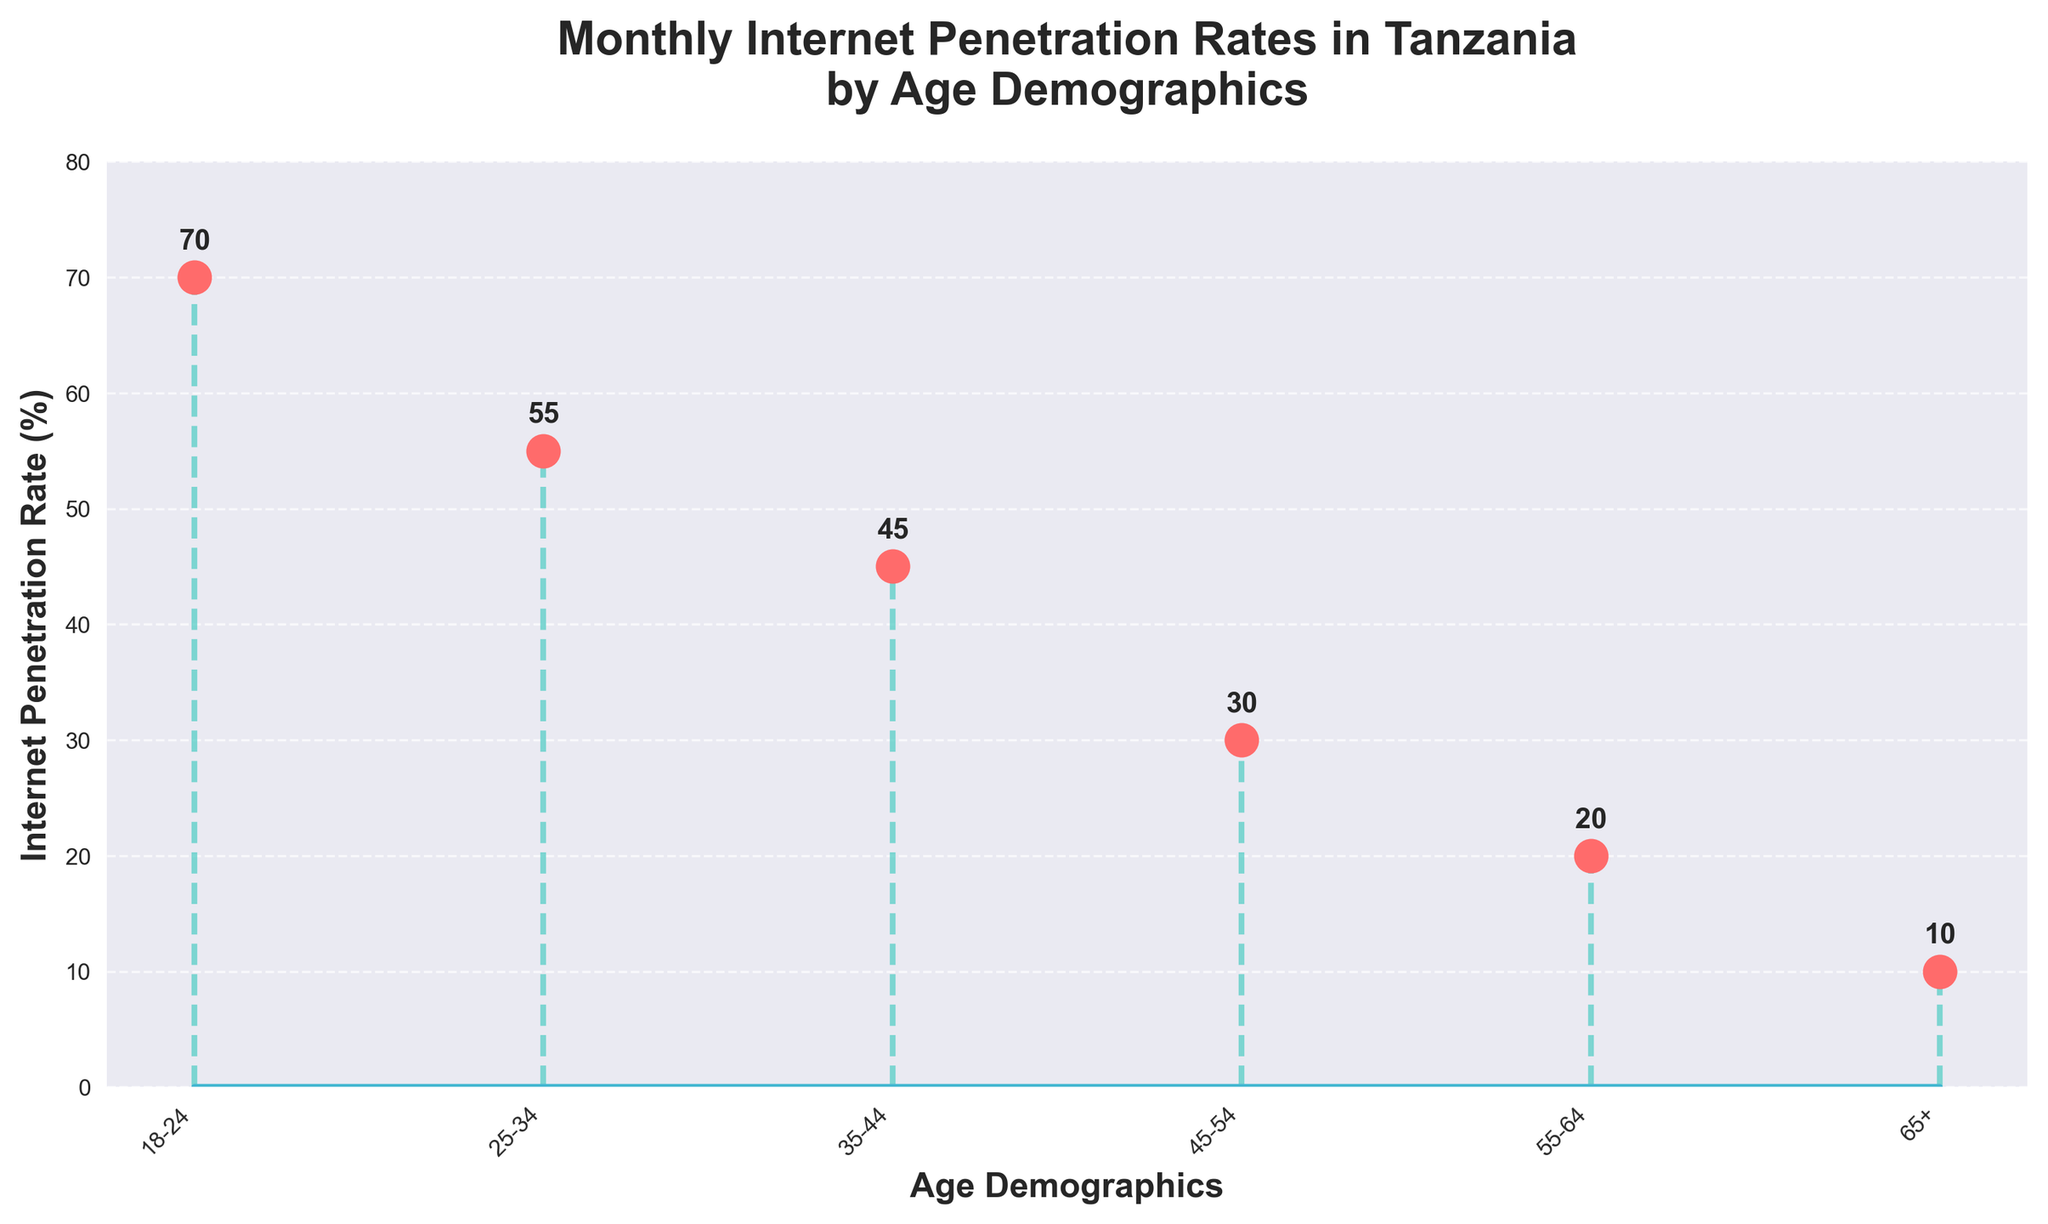What is the internet penetration rate for the 25-34 age demographic? Refer to the y-axis value aligned with the label "25-34" on the x-axis. This value is stated directly above the data point in the plot.
Answer: 55 What is the range of internet penetration rates in the plot? Identify the highest and lowest internet penetration rates from the y-axis values. The highest is 70 and the lowest is 10. Calculate the range as 70 - 10.
Answer: 60 Which age demographic has the lowest internet penetration rate? Find the demographic with the lowest y-axis value. The age demographic corresponding to this value is "65+".
Answer: 65+ How does the internet penetration rate for the 45-54 age group compare to the 18-24 age group? Compare the y-axis values for "45-54" and "18-24". The value for 45-54 is 30, and the value for 18-24 is 70.
Answer: 45-54 has less penetration What is the average internet penetration rate across all age demographics? Sum the internet penetration rates (70 + 55 + 45 + 30 + 20 + 10) and divide by the number of age demographics (6).
Answer: 38.33 By how much does the internet penetration rate decrease from the 18-24 age group to the 25-34 age group? Subtract the y-axis value for the 25-34 age group (55) from the y-axis value for the 18-24 age group (70).
Answer: 15 What is the internet penetration rate for the 55-64 age demographic? Refer to the y-axis value aligned with the label "55-64" on the x-axis. This value is stated directly above the data point in the plot.
Answer: 20 Which age demographic shows the largest drop in internet penetration rate compared to the previous group? Calculate the differences between consecutive age group y-values (70-55, 55-45, 45-30, 30-20, 20-10) and identify the largest drop (15 for 45-54).
Answer: 45-54 What is the total internet penetration rate for all the age demographics summed together? Add the internet penetration rates for all age demographics: 70 + 55 + 45 + 30 + 20 + 10.
Answer: 230 What is the median internet penetration rate in the figure? Arrange the y-axis values in ascending order (10, 20, 30, 45, 55, 70). The median is the average of the middle two values (30 and 45).
Answer: 37.5 